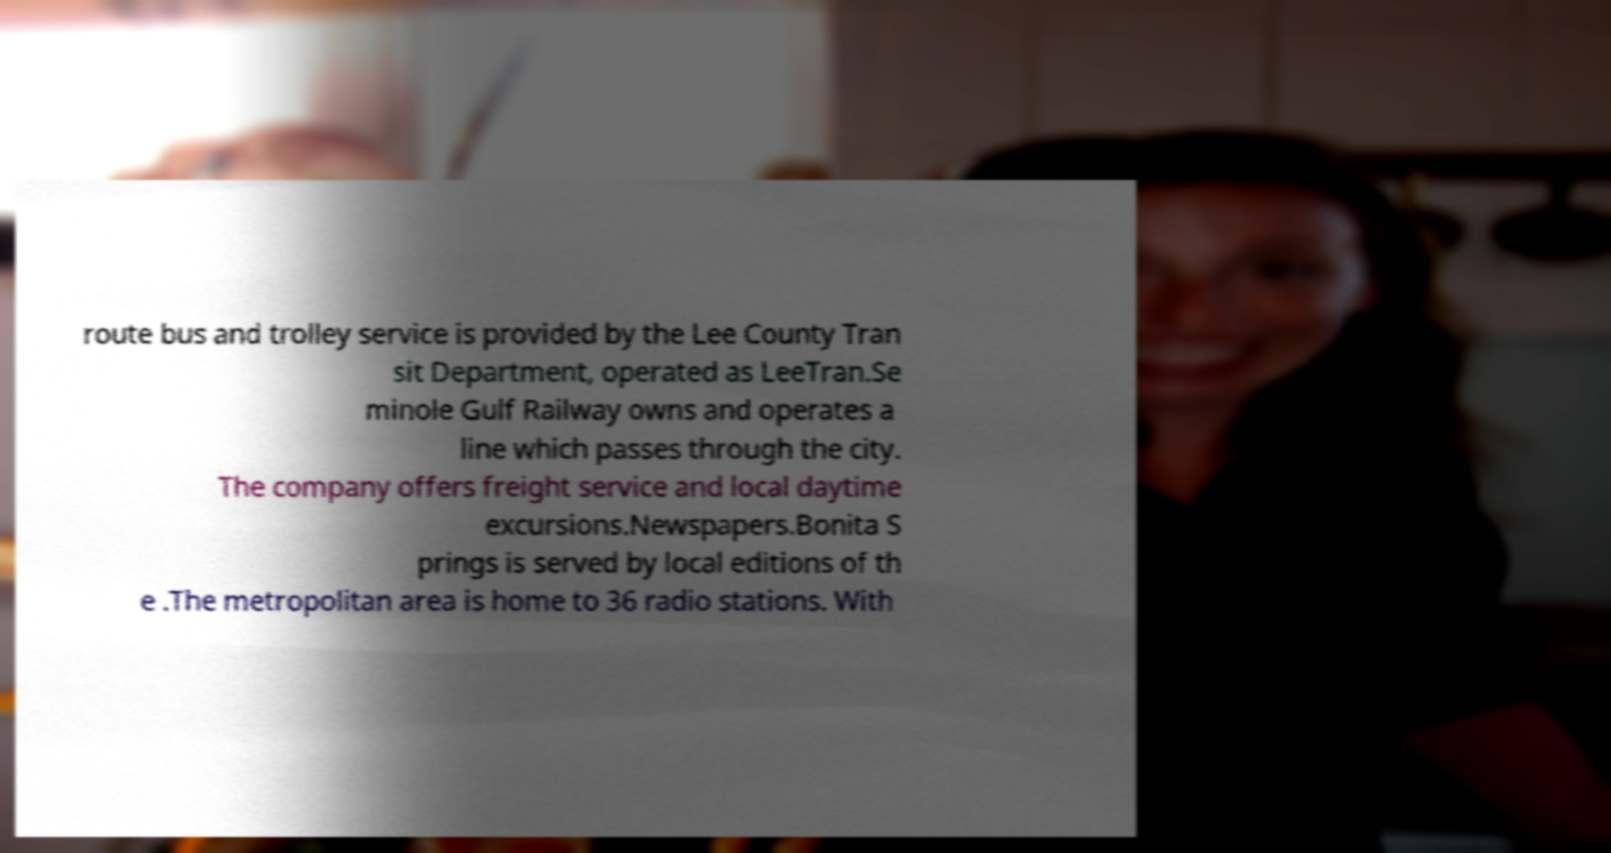Please read and relay the text visible in this image. What does it say? route bus and trolley service is provided by the Lee County Tran sit Department, operated as LeeTran.Se minole Gulf Railway owns and operates a line which passes through the city. The company offers freight service and local daytime excursions.Newspapers.Bonita S prings is served by local editions of th e .The metropolitan area is home to 36 radio stations. With 